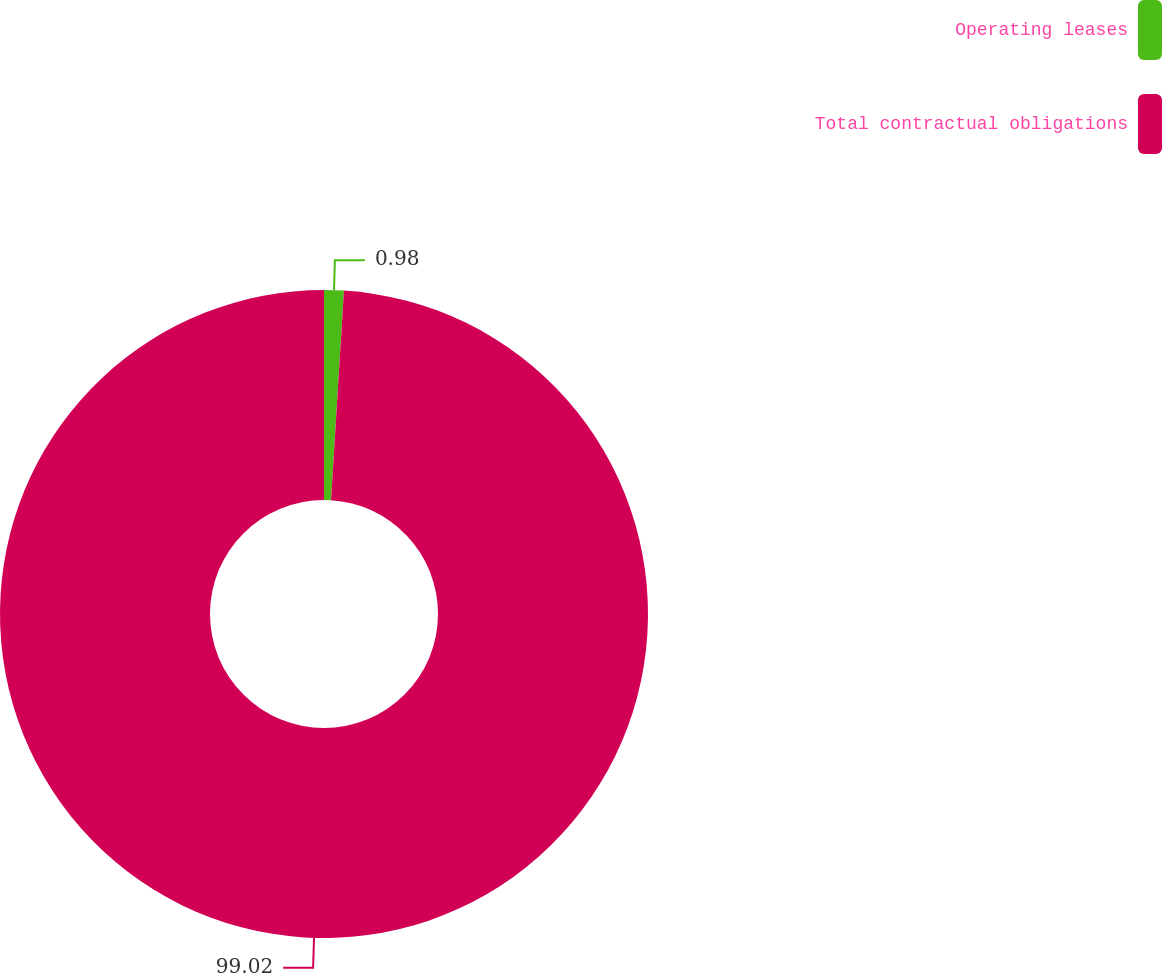Convert chart to OTSL. <chart><loc_0><loc_0><loc_500><loc_500><pie_chart><fcel>Operating leases<fcel>Total contractual obligations<nl><fcel>0.98%<fcel>99.02%<nl></chart> 